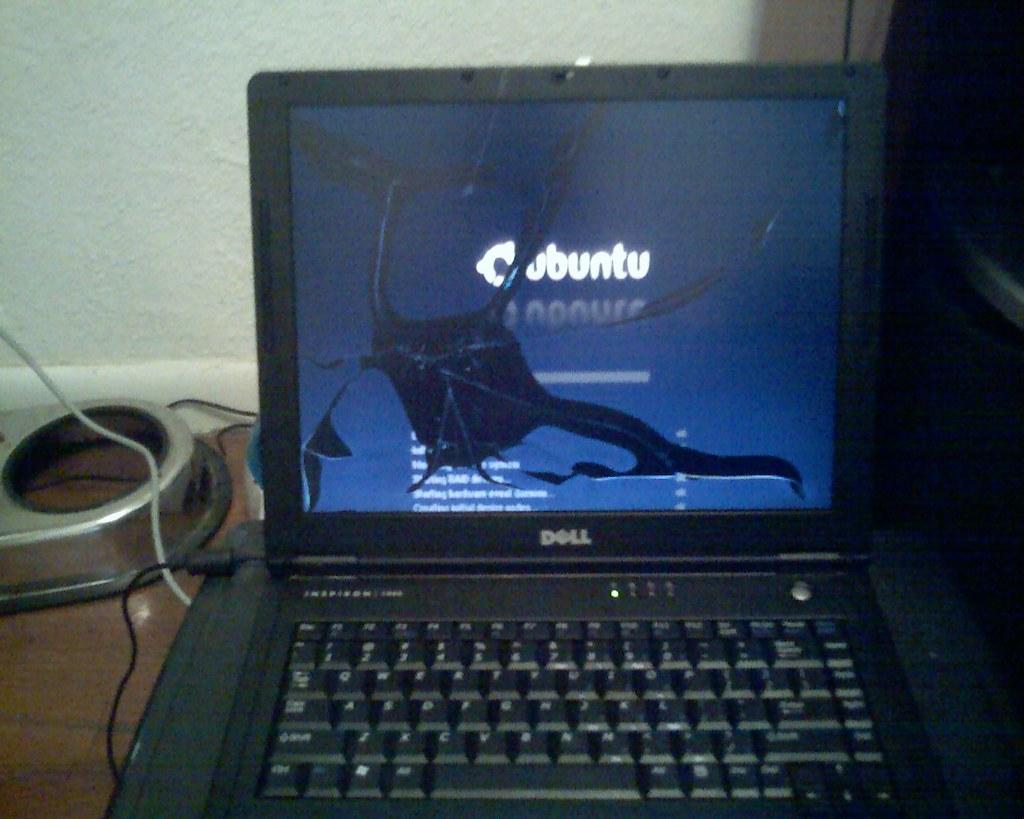What is the maker of the computer?
Your answer should be compact. Dell. What operating system is being used?
Give a very brief answer. Ubuntu. 